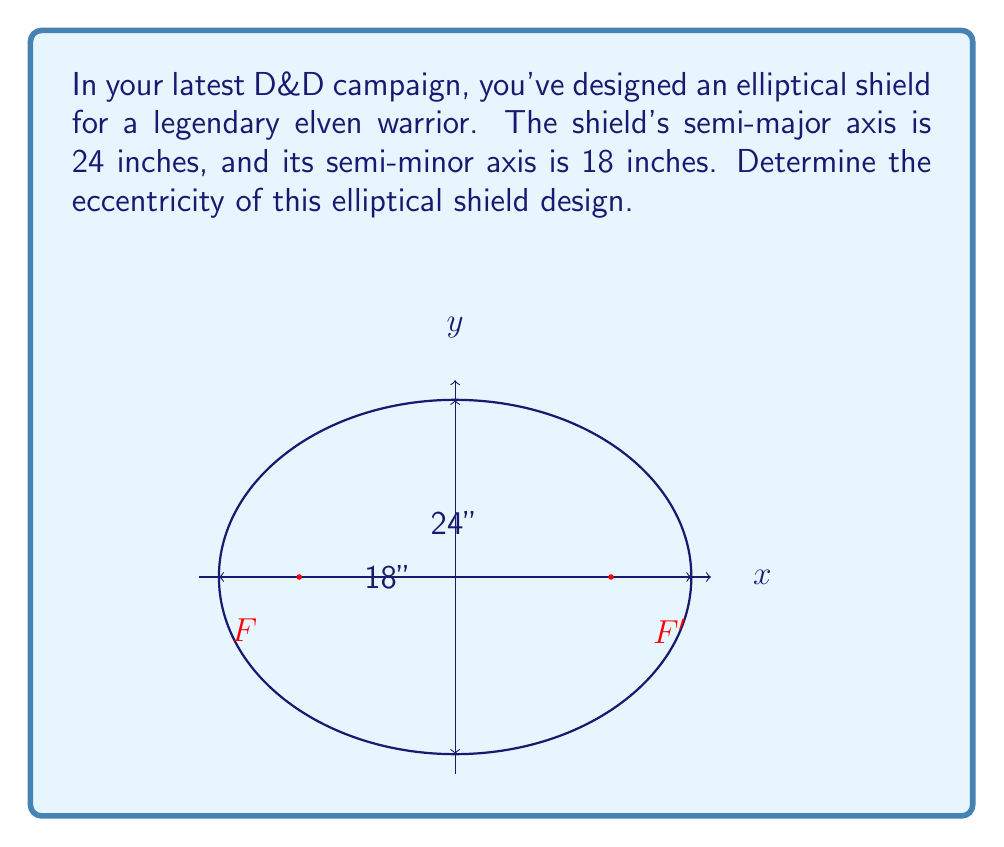Provide a solution to this math problem. Let's approach this step-by-step:

1) The eccentricity of an ellipse is defined as:

   $$e = \frac{\sqrt{a^2 - b^2}}{a}$$

   where $a$ is the semi-major axis and $b$ is the semi-minor axis.

2) We're given:
   - Semi-major axis $a = 24$ inches
   - Semi-minor axis $b = 18$ inches

3) Let's substitute these values into the eccentricity formula:

   $$e = \frac{\sqrt{24^2 - 18^2}}{24}$$

4) Simplify under the square root:
   
   $$e = \frac{\sqrt{576 - 324}}{24} = \frac{\sqrt{252}}{24}$$

5) Simplify further:
   
   $$e = \frac{\sqrt{36 \cdot 7}}{24} = \frac{6\sqrt{7}}{24}$$

6) Reduce the fraction:
   
   $$e = \frac{\sqrt{7}}{4}$$

This fraction cannot be simplified further, so this is our final answer.
Answer: $\frac{\sqrt{7}}{4}$ 